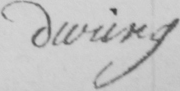What text is written in this handwritten line? during 